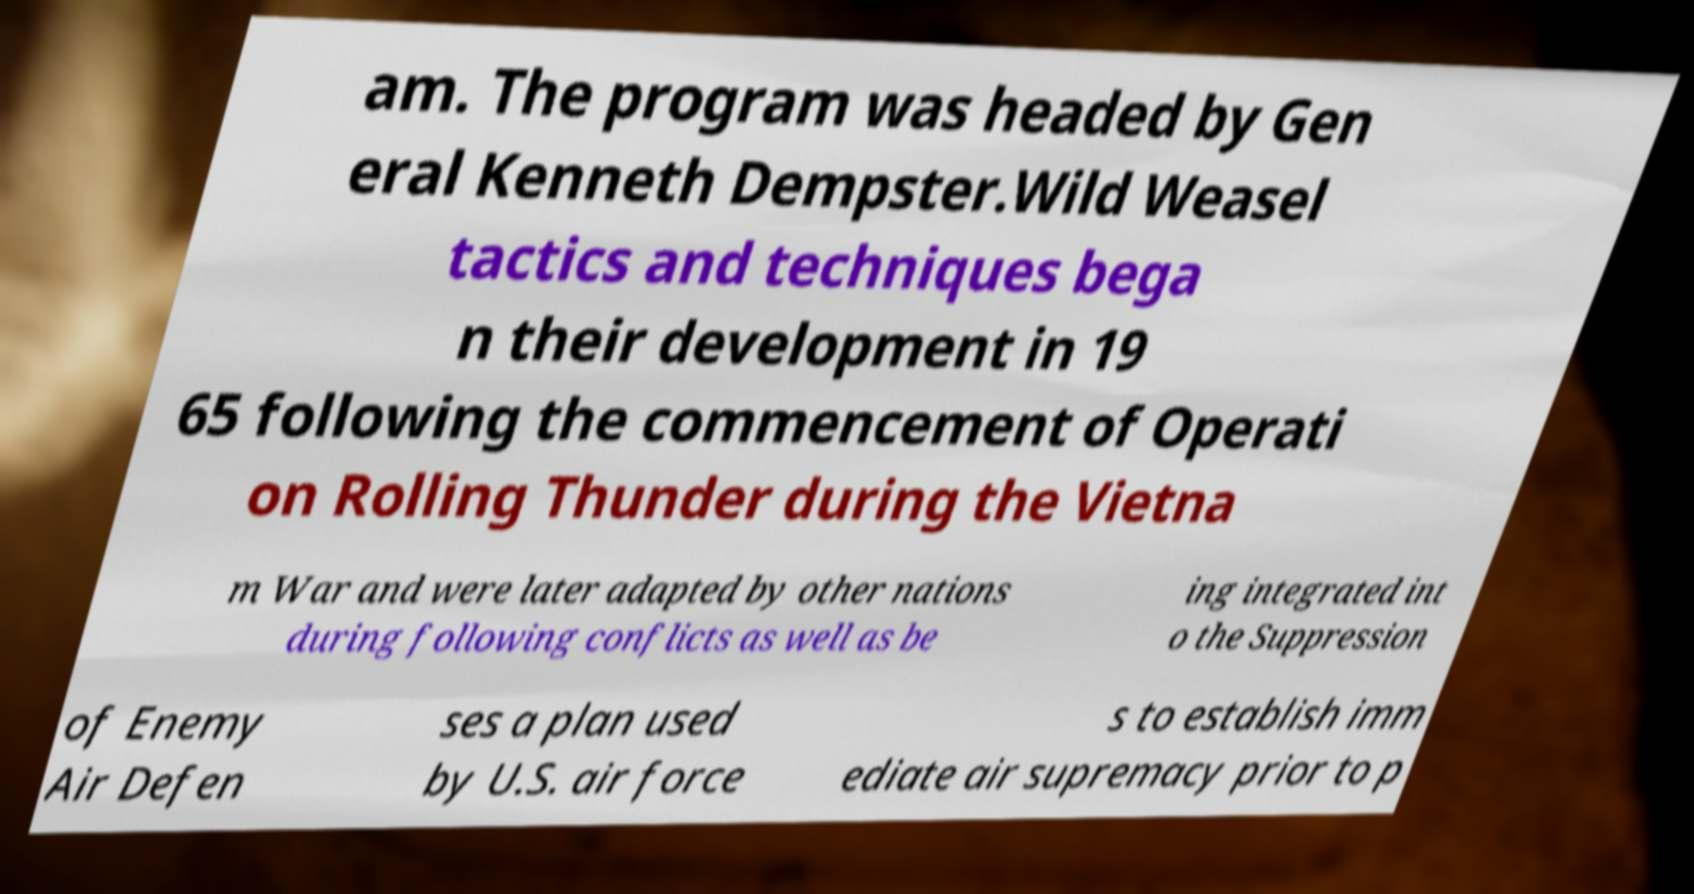There's text embedded in this image that I need extracted. Can you transcribe it verbatim? am. The program was headed by Gen eral Kenneth Dempster.Wild Weasel tactics and techniques bega n their development in 19 65 following the commencement of Operati on Rolling Thunder during the Vietna m War and were later adapted by other nations during following conflicts as well as be ing integrated int o the Suppression of Enemy Air Defen ses a plan used by U.S. air force s to establish imm ediate air supremacy prior to p 